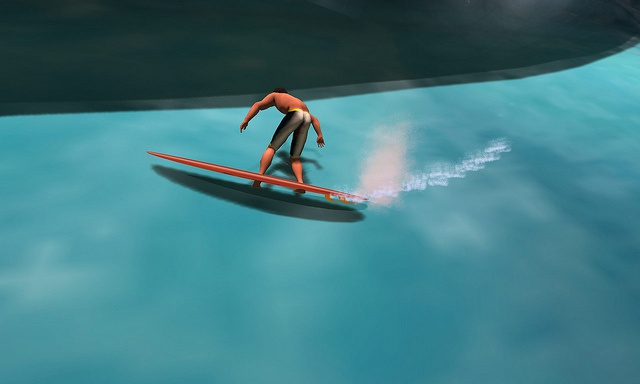Describe the objects in this image and their specific colors. I can see people in black, salmon, maroon, and brown tones, surfboard in black, brown, and salmon tones, and surfboard in black, brown, darkgray, and lightpink tones in this image. 